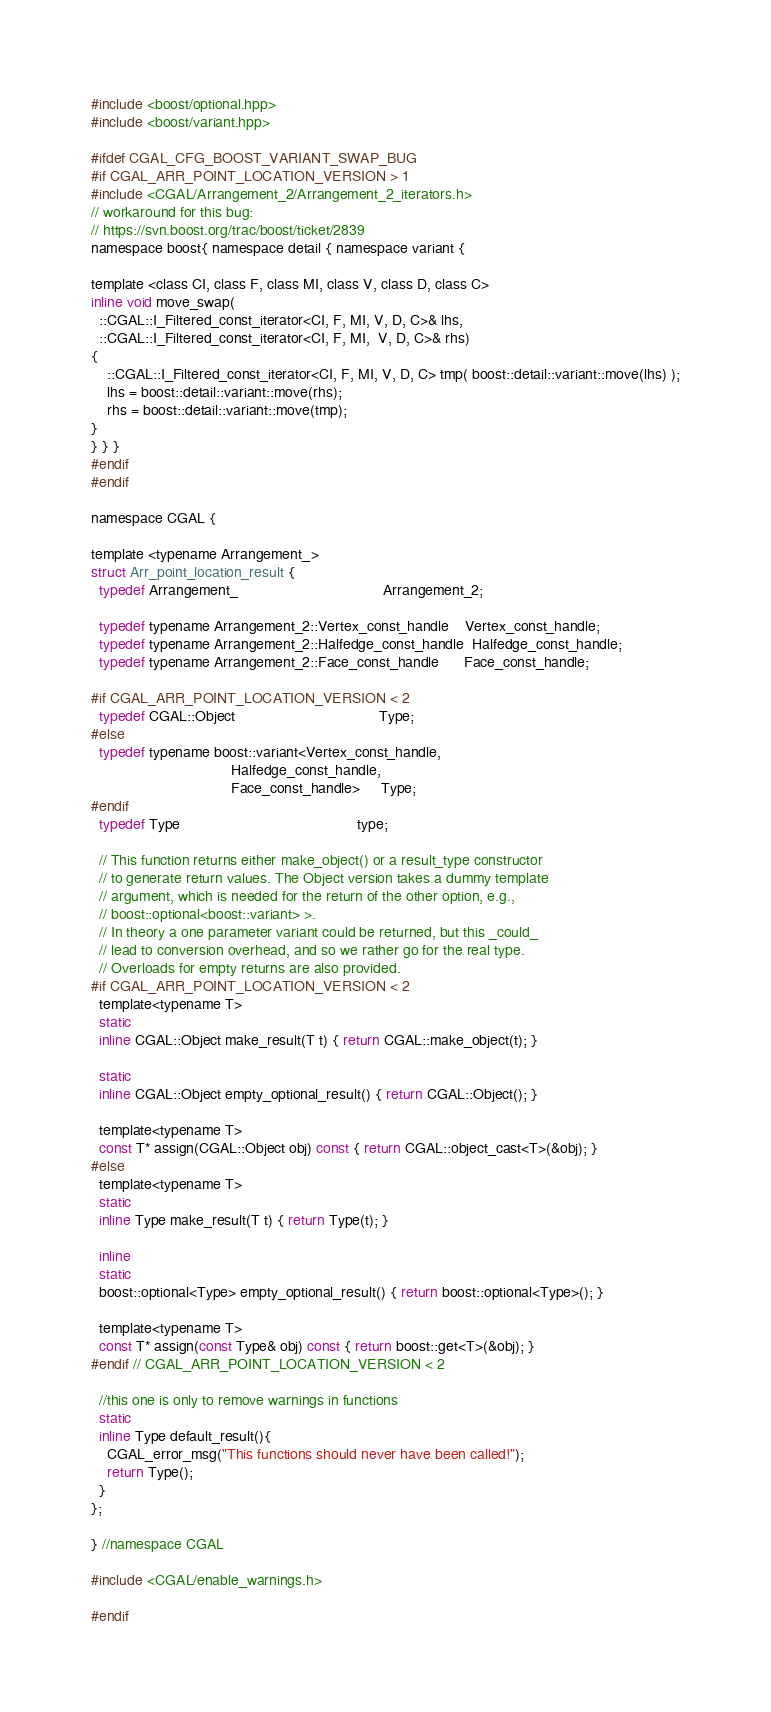Convert code to text. <code><loc_0><loc_0><loc_500><loc_500><_C_>#include <boost/optional.hpp>
#include <boost/variant.hpp>

#ifdef CGAL_CFG_BOOST_VARIANT_SWAP_BUG
#if CGAL_ARR_POINT_LOCATION_VERSION > 1
#include <CGAL/Arrangement_2/Arrangement_2_iterators.h>
// workaround for this bug:
// https://svn.boost.org/trac/boost/ticket/2839
namespace boost{ namespace detail { namespace variant {

template <class CI, class F, class MI, class V, class D, class C>
inline void move_swap(
  ::CGAL::I_Filtered_const_iterator<CI, F, MI, V, D, C>& lhs,
  ::CGAL::I_Filtered_const_iterator<CI, F, MI,  V, D, C>& rhs)
{
    ::CGAL::I_Filtered_const_iterator<CI, F, MI, V, D, C> tmp( boost::detail::variant::move(lhs) );
    lhs = boost::detail::variant::move(rhs);
    rhs = boost::detail::variant::move(tmp);
}
} } }
#endif
#endif

namespace CGAL {

template <typename Arrangement_>
struct Arr_point_location_result {
  typedef Arrangement_                                   Arrangement_2;

  typedef typename Arrangement_2::Vertex_const_handle    Vertex_const_handle;
  typedef typename Arrangement_2::Halfedge_const_handle  Halfedge_const_handle;
  typedef typename Arrangement_2::Face_const_handle      Face_const_handle;

#if CGAL_ARR_POINT_LOCATION_VERSION < 2
  typedef CGAL::Object                                   Type;
#else
  typedef typename boost::variant<Vertex_const_handle,
                                  Halfedge_const_handle,
                                  Face_const_handle>     Type;
#endif
  typedef Type                                           type;

  // This function returns either make_object() or a result_type constructor
  // to generate return values. The Object version takes a dummy template
  // argument, which is needed for the return of the other option, e.g.,
  // boost::optional<boost::variant> >.
  // In theory a one parameter variant could be returned, but this _could_
  // lead to conversion overhead, and so we rather go for the real type.
  // Overloads for empty returns are also provided.
#if CGAL_ARR_POINT_LOCATION_VERSION < 2
  template<typename T>
  static
  inline CGAL::Object make_result(T t) { return CGAL::make_object(t); }

  static
  inline CGAL::Object empty_optional_result() { return CGAL::Object(); }

  template<typename T>
  const T* assign(CGAL::Object obj) const { return CGAL::object_cast<T>(&obj); }
#else
  template<typename T>
  static
  inline Type make_result(T t) { return Type(t); }

  inline
  static
  boost::optional<Type> empty_optional_result() { return boost::optional<Type>(); }

  template<typename T>
  const T* assign(const Type& obj) const { return boost::get<T>(&obj); }
#endif // CGAL_ARR_POINT_LOCATION_VERSION < 2

  //this one is only to remove warnings in functions
  static
  inline Type default_result(){
    CGAL_error_msg("This functions should never have been called!");
    return Type();
  }
};

} //namespace CGAL

#include <CGAL/enable_warnings.h>

#endif
</code> 